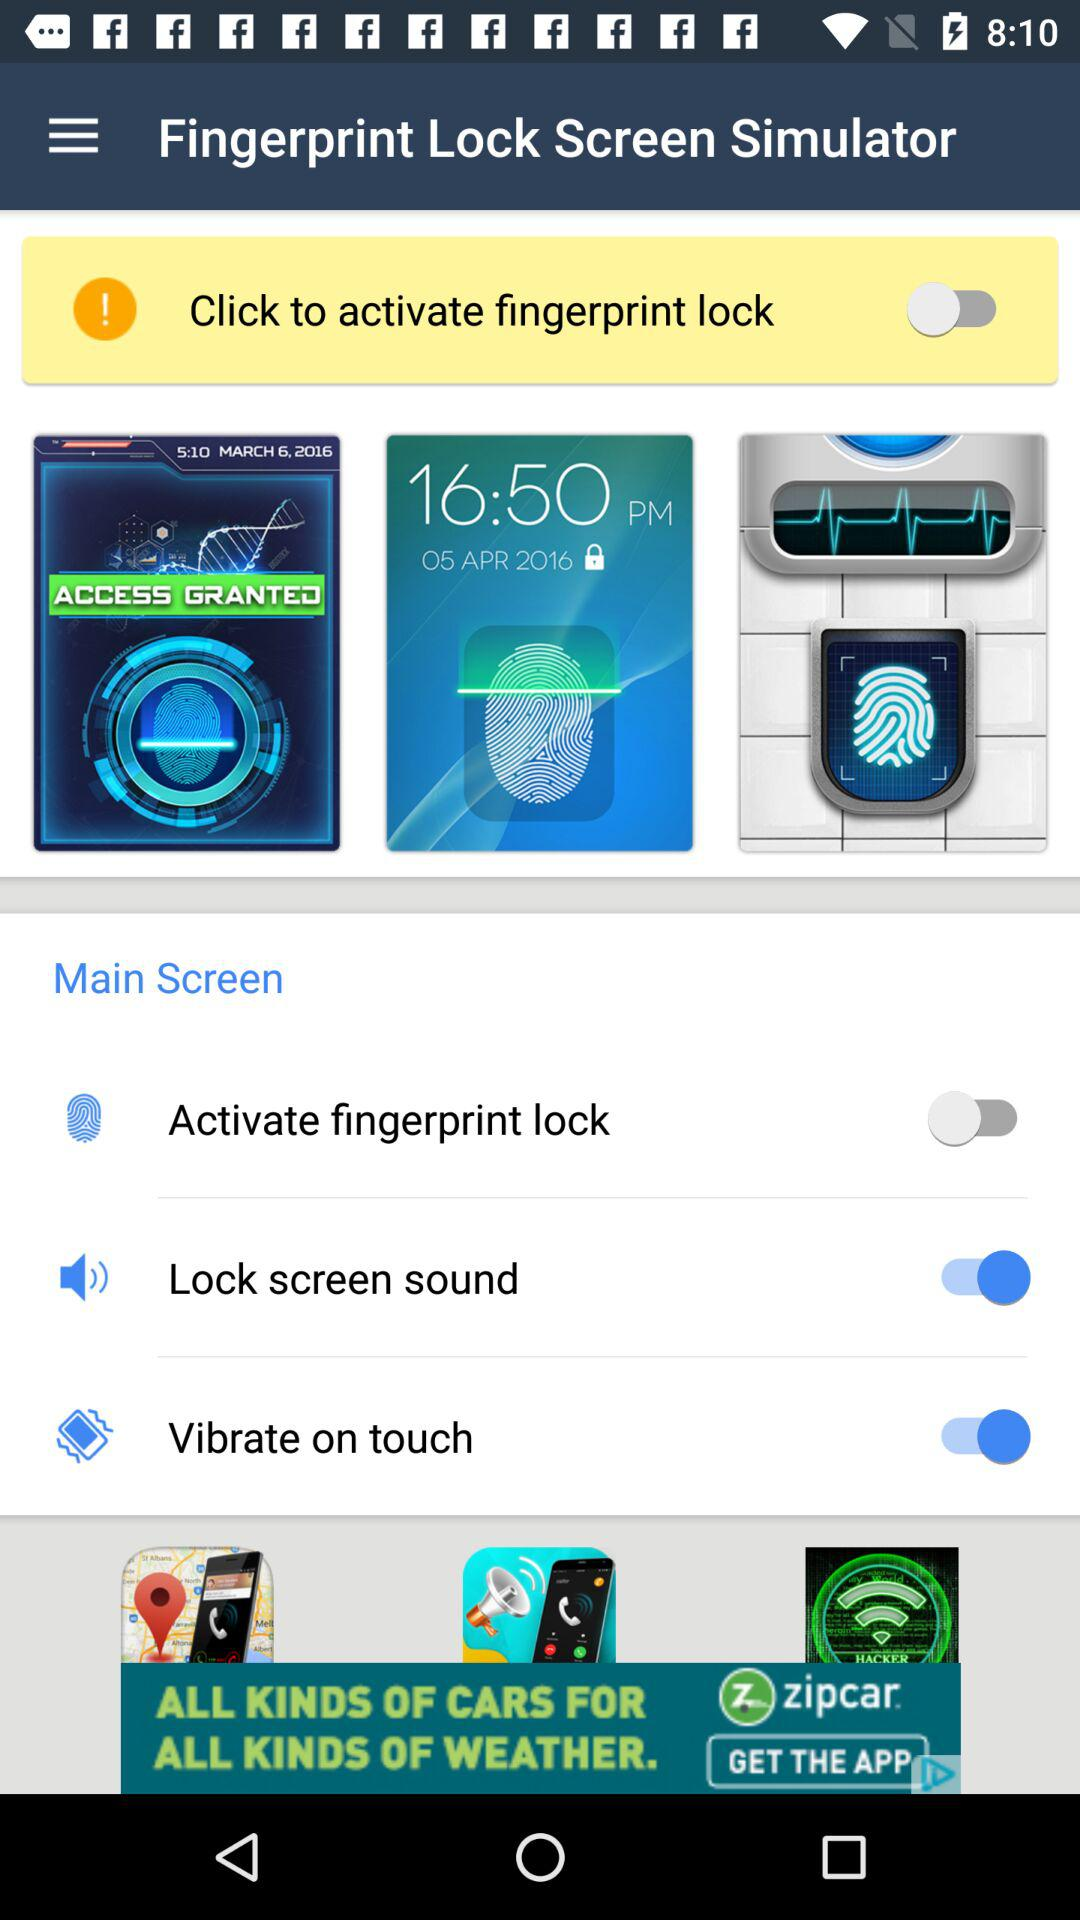What is the application name? The application name is "Fingerprint Lock Screen Simulator". 